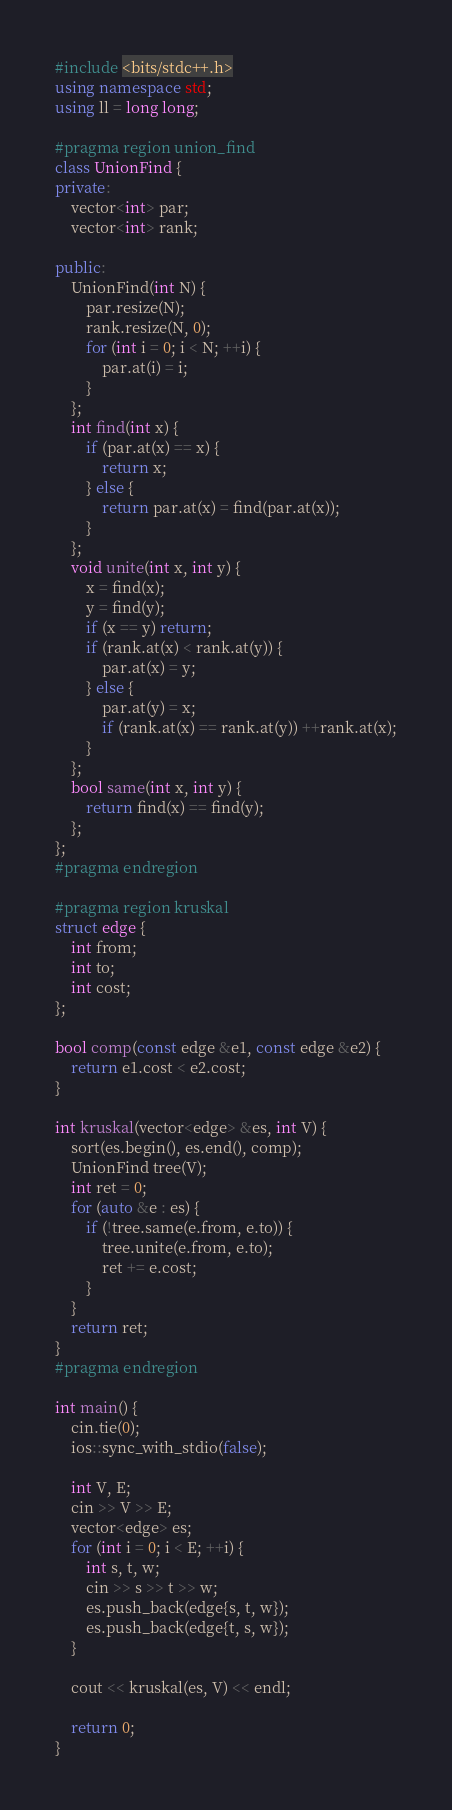Convert code to text. <code><loc_0><loc_0><loc_500><loc_500><_C++_>#include <bits/stdc++.h>
using namespace std;
using ll = long long;

#pragma region union_find
class UnionFind {
private:
    vector<int> par;
    vector<int> rank;

public:
    UnionFind(int N) {
        par.resize(N);
        rank.resize(N, 0);
        for (int i = 0; i < N; ++i) {
            par.at(i) = i;
        }
    };
    int find(int x) {
        if (par.at(x) == x) {
            return x;
        } else {
            return par.at(x) = find(par.at(x));
        }
    };
    void unite(int x, int y) {
        x = find(x);
        y = find(y);
        if (x == y) return;
        if (rank.at(x) < rank.at(y)) {
            par.at(x) = y;
        } else {
            par.at(y) = x;
            if (rank.at(x) == rank.at(y)) ++rank.at(x);
        }
    };
    bool same(int x, int y) {
        return find(x) == find(y);
    };
};
#pragma endregion

#pragma region kruskal
struct edge {
    int from;
    int to;
    int cost;
};

bool comp(const edge &e1, const edge &e2) {
    return e1.cost < e2.cost;
}

int kruskal(vector<edge> &es, int V) {
    sort(es.begin(), es.end(), comp);
    UnionFind tree(V);
    int ret = 0;
    for (auto &e : es) {
        if (!tree.same(e.from, e.to)) {
            tree.unite(e.from, e.to);
            ret += e.cost;
        }
    }
    return ret;
}
#pragma endregion

int main() {
    cin.tie(0);
    ios::sync_with_stdio(false);

    int V, E;
    cin >> V >> E;
    vector<edge> es;
    for (int i = 0; i < E; ++i) {
        int s, t, w;
        cin >> s >> t >> w;
        es.push_back(edge{s, t, w});
        es.push_back(edge{t, s, w});
    }

    cout << kruskal(es, V) << endl;

    return 0;
}
</code> 